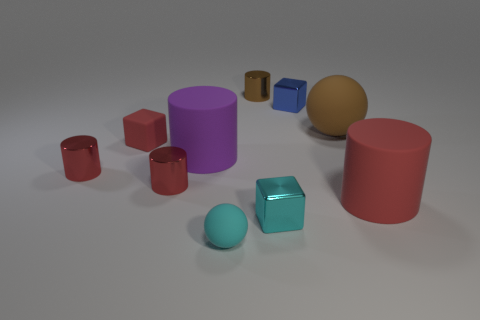Subtract all blue blocks. How many red cylinders are left? 3 Subtract all purple cylinders. How many cylinders are left? 4 Subtract all big red rubber cylinders. How many cylinders are left? 4 Subtract 1 cylinders. How many cylinders are left? 4 Subtract all brown cylinders. Subtract all blue blocks. How many cylinders are left? 4 Subtract all blocks. How many objects are left? 7 Subtract all tiny cyan rubber objects. Subtract all small red blocks. How many objects are left? 8 Add 3 brown cylinders. How many brown cylinders are left? 4 Add 9 red cubes. How many red cubes exist? 10 Subtract 0 yellow cylinders. How many objects are left? 10 